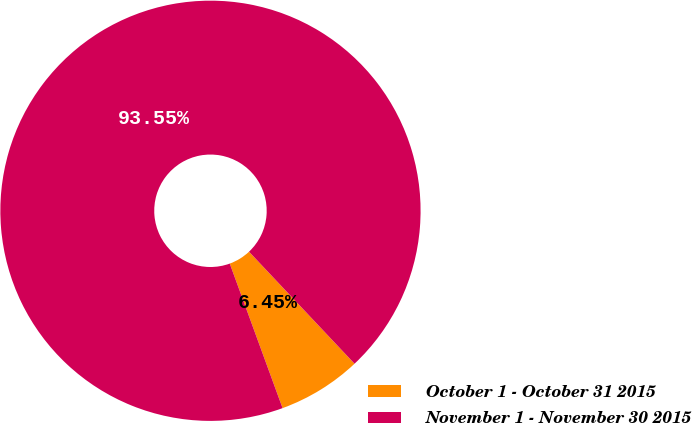<chart> <loc_0><loc_0><loc_500><loc_500><pie_chart><fcel>October 1 - October 31 2015<fcel>November 1 - November 30 2015<nl><fcel>6.45%<fcel>93.55%<nl></chart> 